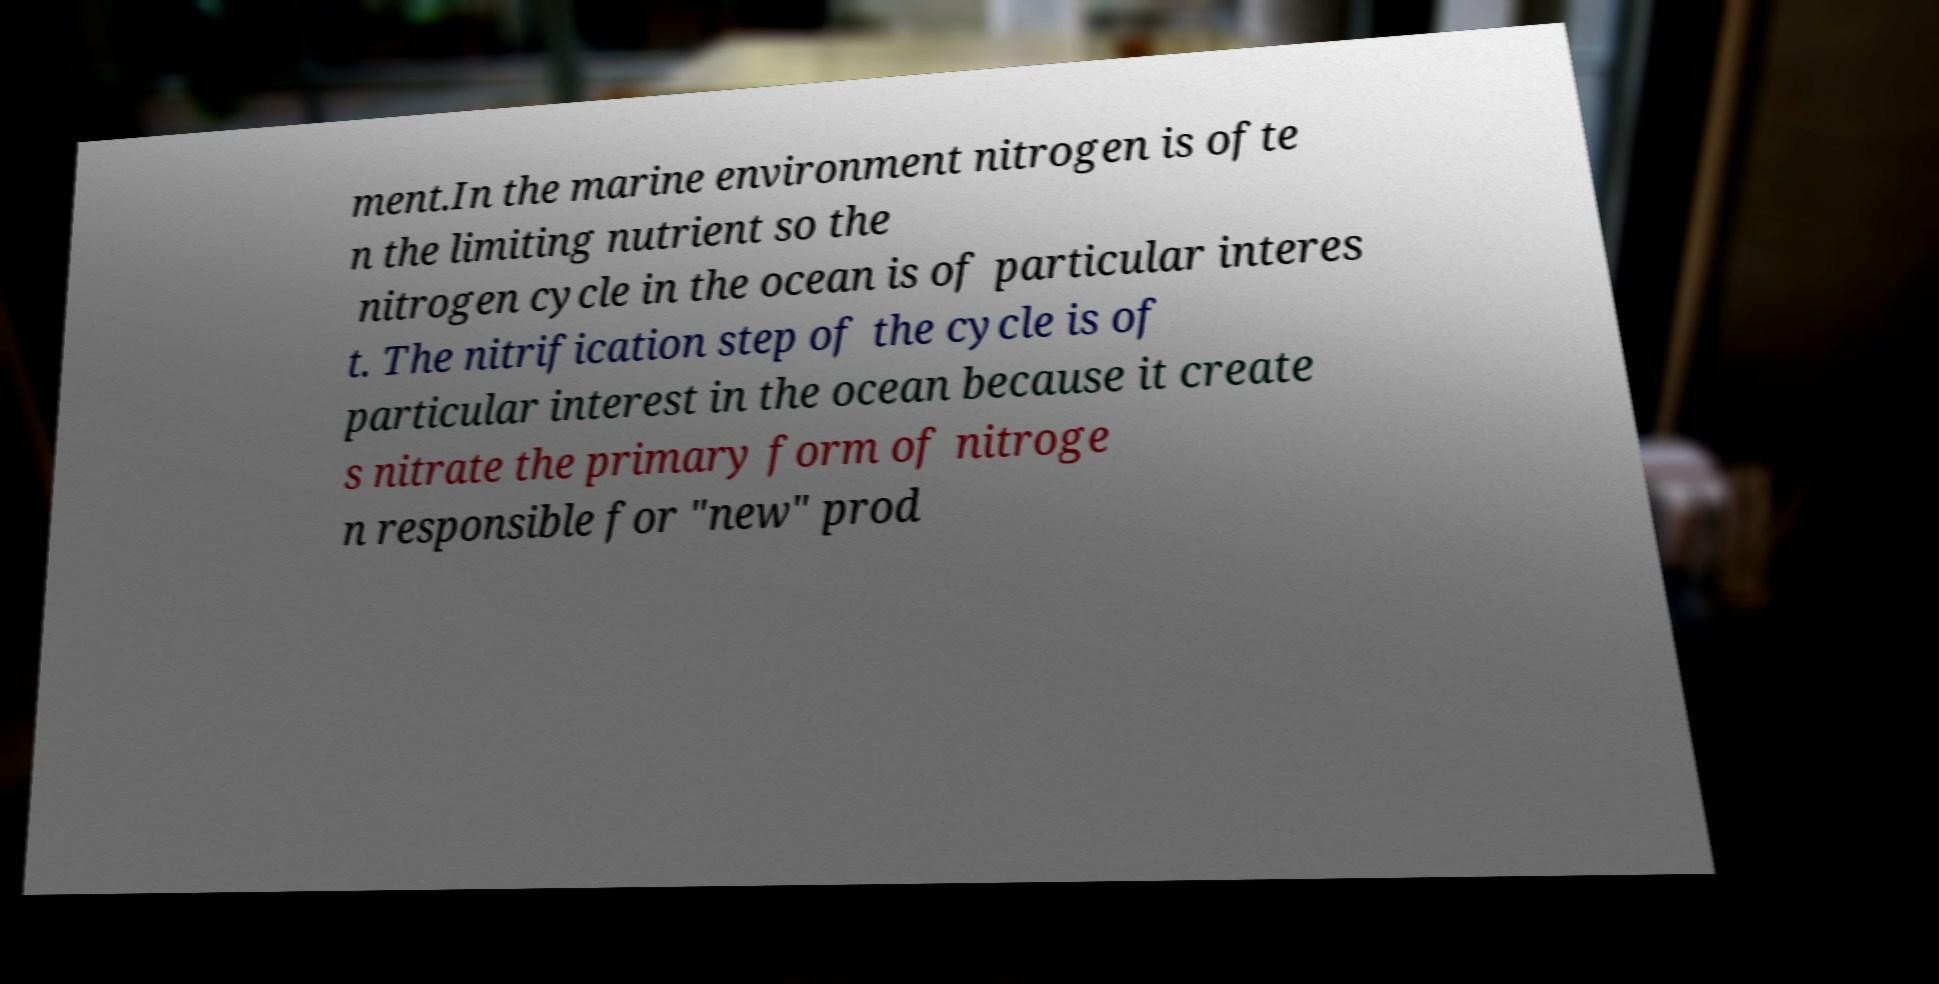What messages or text are displayed in this image? I need them in a readable, typed format. ment.In the marine environment nitrogen is ofte n the limiting nutrient so the nitrogen cycle in the ocean is of particular interes t. The nitrification step of the cycle is of particular interest in the ocean because it create s nitrate the primary form of nitroge n responsible for "new" prod 